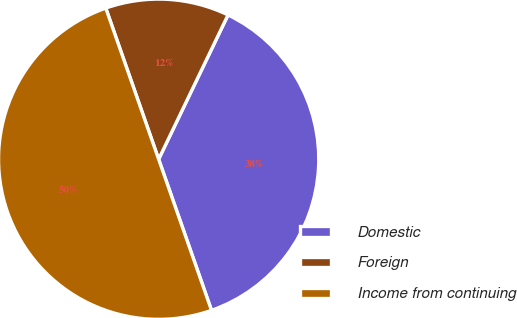Convert chart. <chart><loc_0><loc_0><loc_500><loc_500><pie_chart><fcel>Domestic<fcel>Foreign<fcel>Income from continuing<nl><fcel>37.51%<fcel>12.49%<fcel>50.0%<nl></chart> 